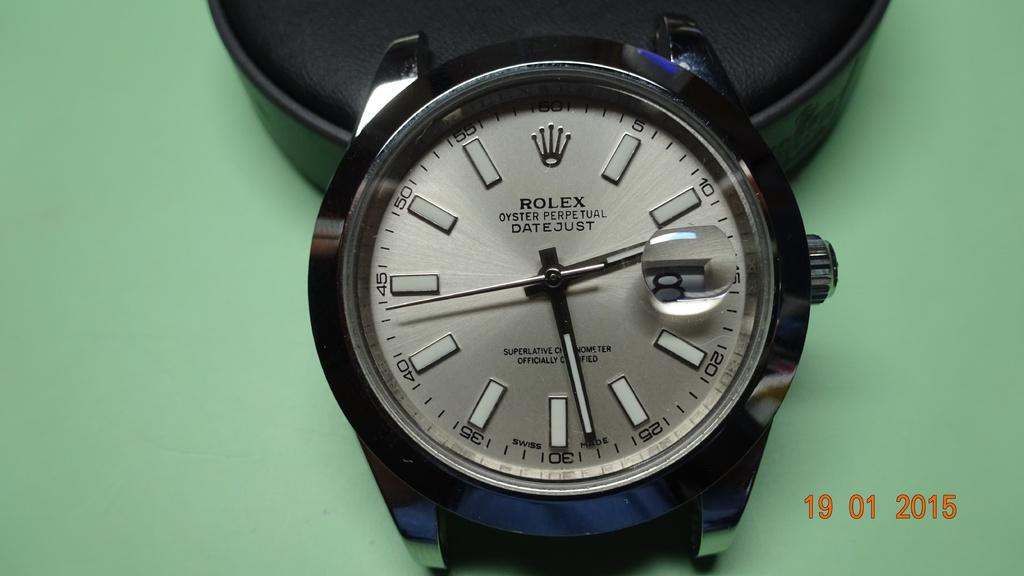<image>
Give a short and clear explanation of the subsequent image. A very expensive rolex watch that displays seconds as numbers. 